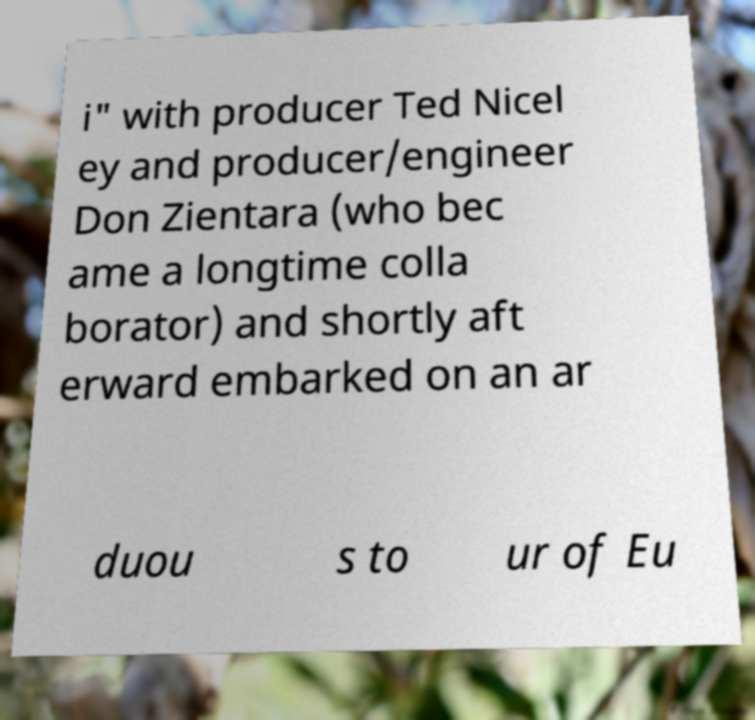Please read and relay the text visible in this image. What does it say? i" with producer Ted Nicel ey and producer/engineer Don Zientara (who bec ame a longtime colla borator) and shortly aft erward embarked on an ar duou s to ur of Eu 